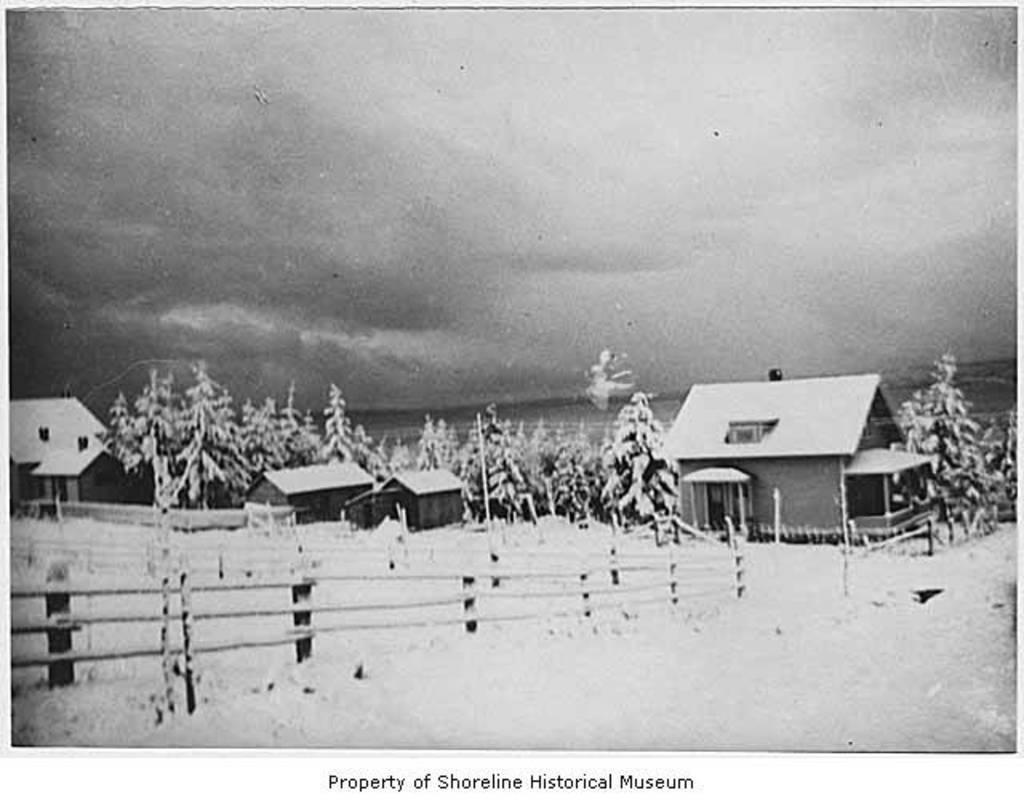How would you summarize this image in a sentence or two? Black and white pictures. Here we can see houses, fence and trees. Bottom of the image there is a watermark. 